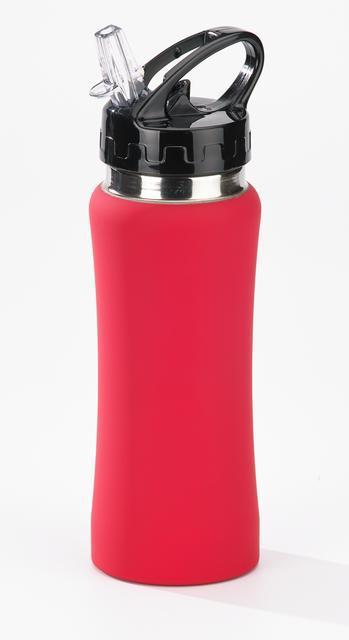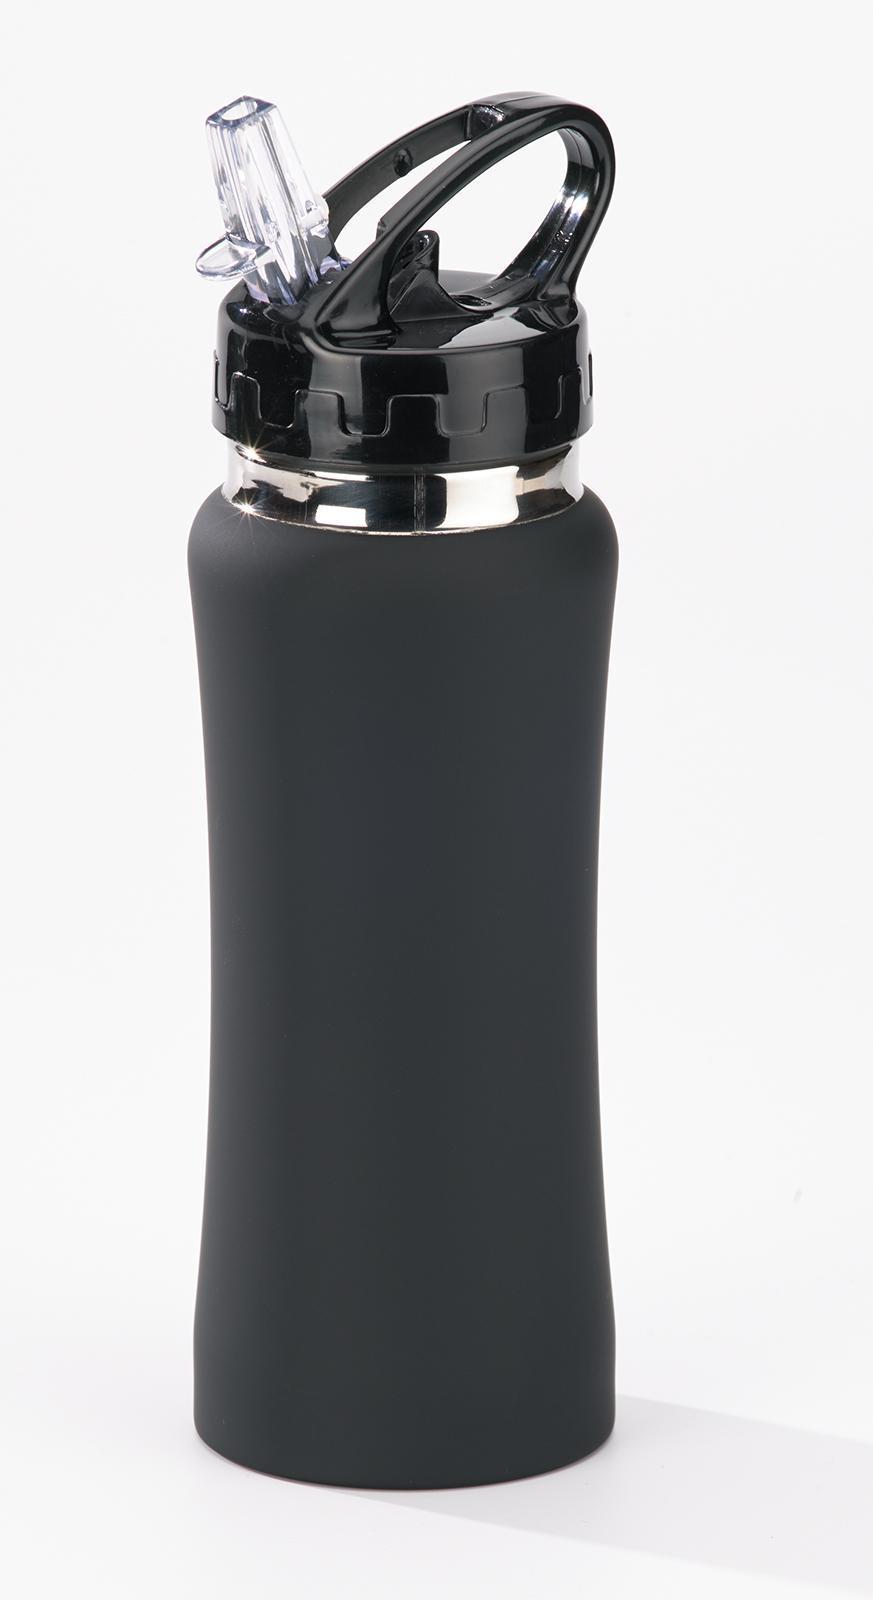The first image is the image on the left, the second image is the image on the right. Evaluate the accuracy of this statement regarding the images: "In at least one image there is a red bottle in front of a box with an engraved package on it.". Is it true? Answer yes or no. No. The first image is the image on the left, the second image is the image on the right. For the images shown, is this caption "The combined images include a white upright box with a sketch of a gift box on it and a red water bottle." true? Answer yes or no. No. 